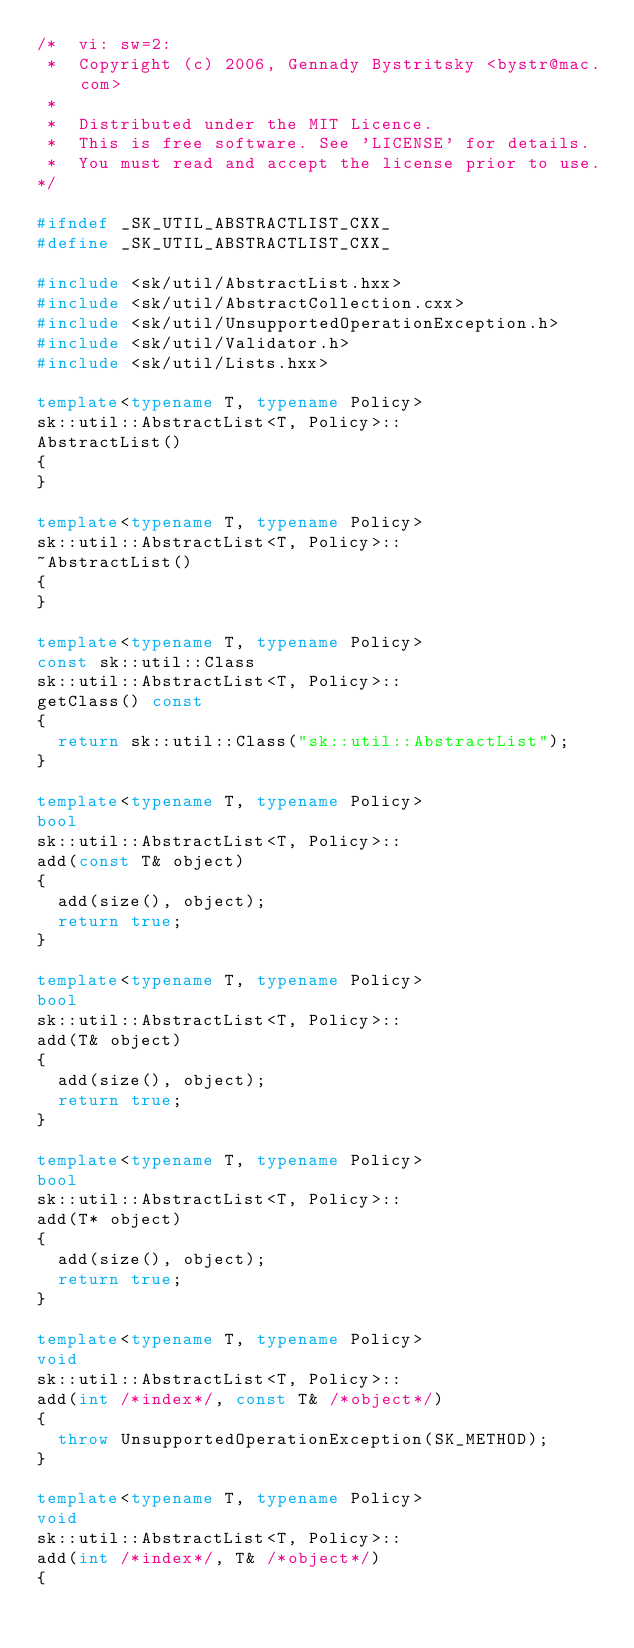<code> <loc_0><loc_0><loc_500><loc_500><_C++_>/*  vi: sw=2:
 *  Copyright (c) 2006, Gennady Bystritsky <bystr@mac.com>
 *
 *  Distributed under the MIT Licence.
 *  This is free software. See 'LICENSE' for details.
 *  You must read and accept the license prior to use.
*/

#ifndef _SK_UTIL_ABSTRACTLIST_CXX_
#define _SK_UTIL_ABSTRACTLIST_CXX_

#include <sk/util/AbstractList.hxx>
#include <sk/util/AbstractCollection.cxx>
#include <sk/util/UnsupportedOperationException.h>
#include <sk/util/Validator.h>
#include <sk/util/Lists.hxx>

template<typename T, typename Policy>
sk::util::AbstractList<T, Policy>::
AbstractList()
{
}

template<typename T, typename Policy>
sk::util::AbstractList<T, Policy>::
~AbstractList()
{
}

template<typename T, typename Policy>
const sk::util::Class
sk::util::AbstractList<T, Policy>::
getClass() const
{
  return sk::util::Class("sk::util::AbstractList");
}

template<typename T, typename Policy>
bool
sk::util::AbstractList<T, Policy>::
add(const T& object)
{
  add(size(), object);
  return true;
}

template<typename T, typename Policy>
bool
sk::util::AbstractList<T, Policy>::
add(T& object)
{
  add(size(), object);
  return true;
}

template<typename T, typename Policy>
bool
sk::util::AbstractList<T, Policy>::
add(T* object)
{
  add(size(), object);
  return true;
}

template<typename T, typename Policy>
void
sk::util::AbstractList<T, Policy>::
add(int /*index*/, const T& /*object*/)
{
  throw UnsupportedOperationException(SK_METHOD);
}

template<typename T, typename Policy>
void
sk::util::AbstractList<T, Policy>::
add(int /*index*/, T& /*object*/)
{</code> 